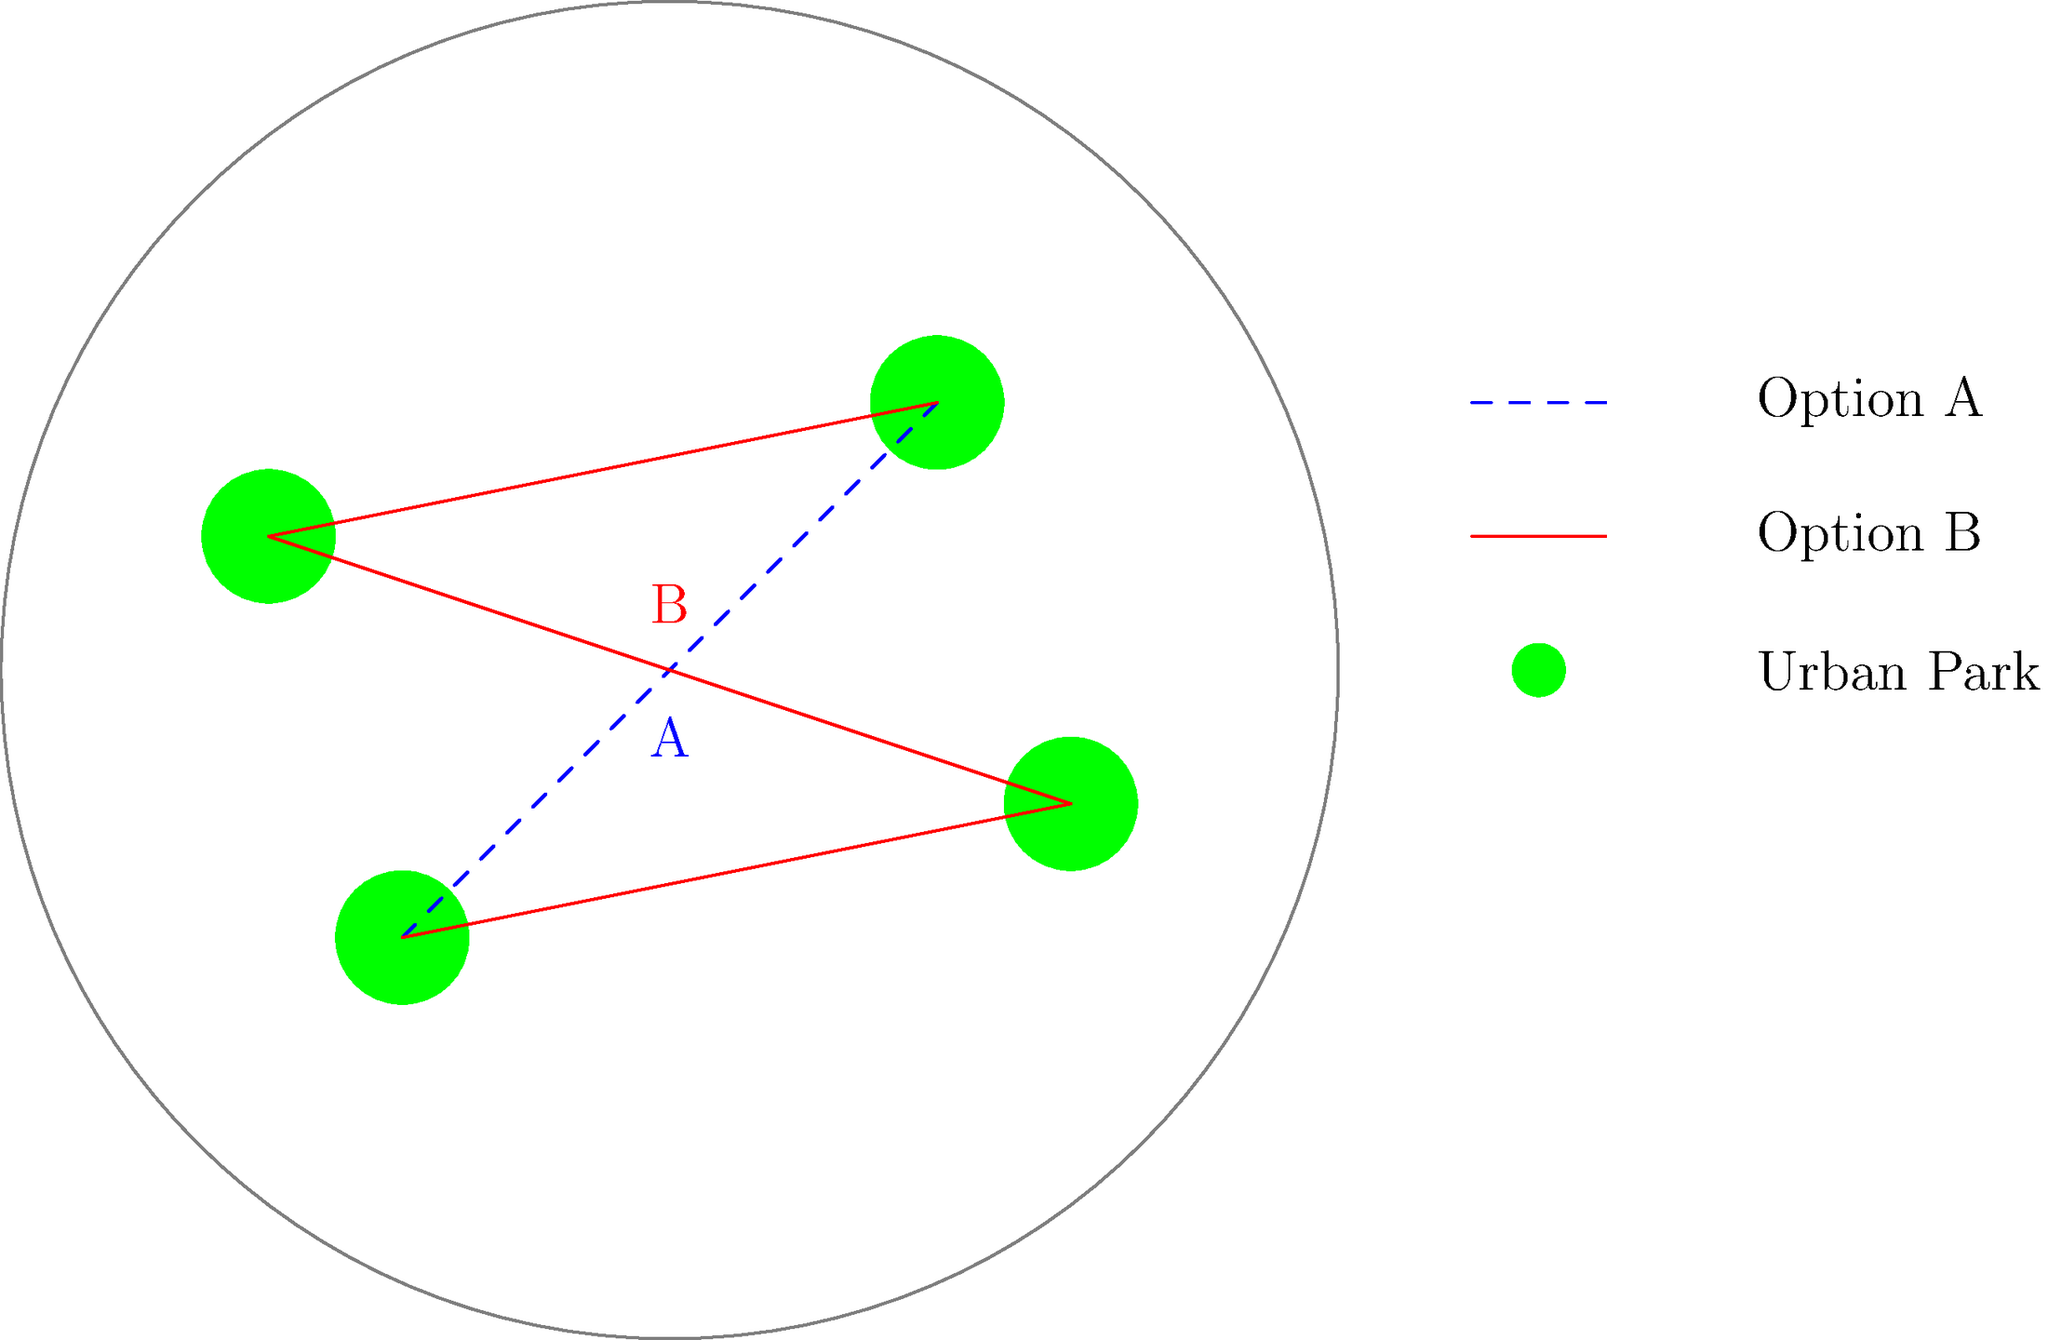Which green corridor design (A or B) would be most effective in connecting the urban parks while maximizing ecosystem connectivity and minimizing habitat fragmentation? To determine the most effective green corridor design, we need to consider several factors:

1. Connectivity: Both options connect all four parks, but we need to examine how directly they do so.

2. Total corridor length: Shorter corridors are generally more cost-effective and easier to implement.

3. Fragmentation: We want to minimize the number of times the corridor crosses urban areas, which can create barriers for wildlife.

4. Directness: More direct routes between parks can facilitate easier movement for wildlife.

Let's analyze each option:

Option A:
- Connects parks in a zig-zag pattern
- Longer total corridor length
- Crosses urban areas more frequently
- Less direct routes between parks

Option B:
- Connects parks in a more circular pattern
- Shorter total corridor length
- Minimizes crossings through urban areas
- More direct routes between parks

Option B is superior because:
1. It provides a more compact and efficient network.
2. It reduces the total corridor length, making it more cost-effective and easier to implement.
3. It minimizes fragmentation by reducing the number of times the corridor crosses through urban areas.
4. It offers more direct routes between parks, facilitating easier movement for wildlife.

These factors combine to create a more effective green corridor that better supports ecosystem connectivity and reduces habitat fragmentation.
Answer: B 